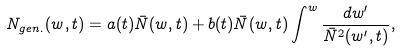<formula> <loc_0><loc_0><loc_500><loc_500>N _ { g e n . } ( w , t ) = a ( t ) \bar { N } ( w , t ) + b ( t ) \bar { N } ( w , t ) \int ^ { w } \frac { d w ^ { \prime } } { \bar { N } ^ { 2 } ( w ^ { \prime } , t ) } ,</formula> 